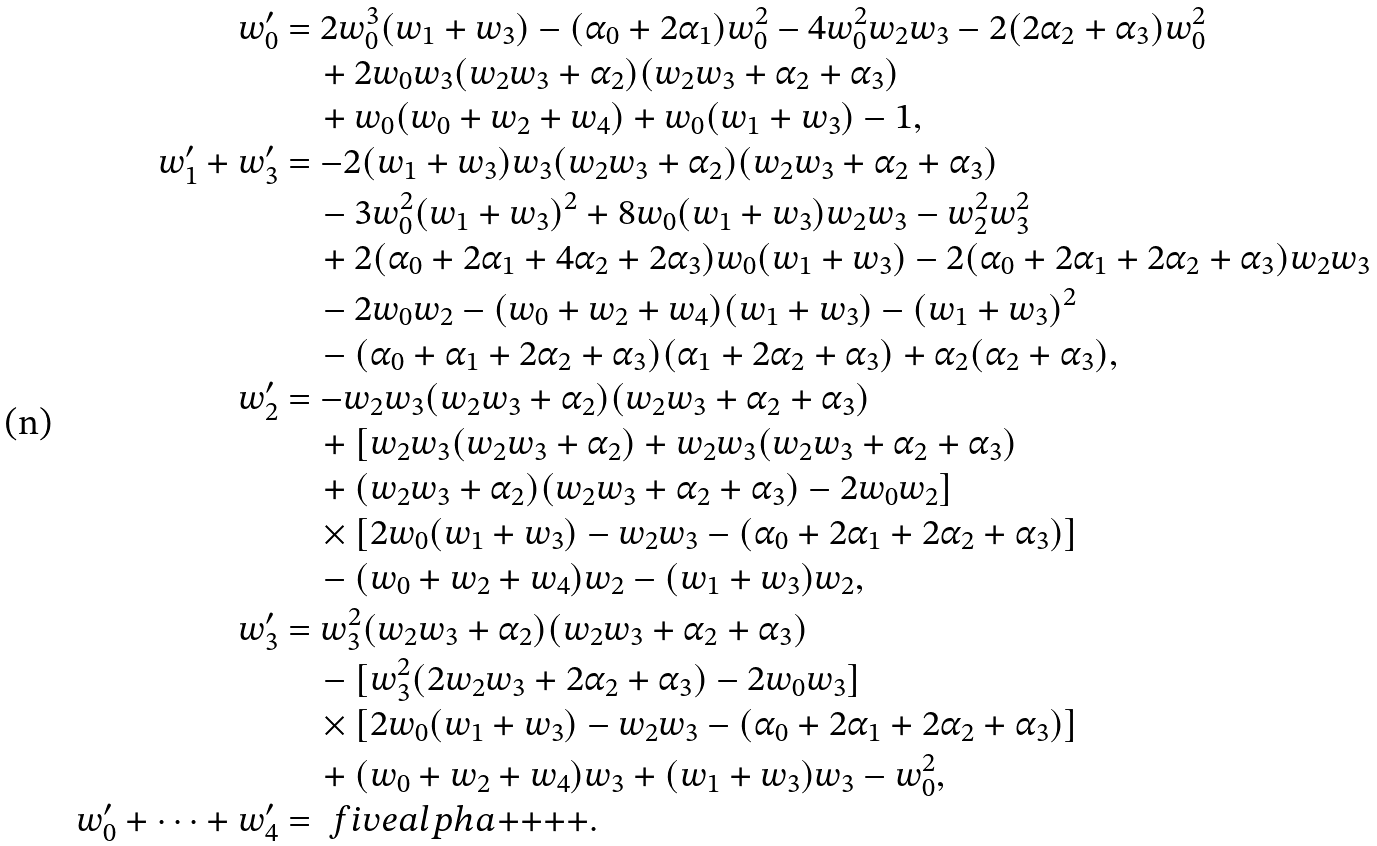<formula> <loc_0><loc_0><loc_500><loc_500>w _ { 0 } ^ { \prime } & = 2 w _ { 0 } ^ { 3 } ( w _ { 1 } + w _ { 3 } ) - ( \alpha _ { 0 } + 2 \alpha _ { 1 } ) w _ { 0 } ^ { 2 } - 4 w _ { 0 } ^ { 2 } w _ { 2 } w _ { 3 } - 2 ( 2 \alpha _ { 2 } + \alpha _ { 3 } ) w _ { 0 } ^ { 2 } \\ & \quad + 2 w _ { 0 } w _ { 3 } ( w _ { 2 } w _ { 3 } + \alpha _ { 2 } ) ( w _ { 2 } w _ { 3 } + \alpha _ { 2 } + \alpha _ { 3 } ) \\ & \quad + w _ { 0 } ( w _ { 0 } + w _ { 2 } + w _ { 4 } ) + w _ { 0 } ( w _ { 1 } + w _ { 3 } ) - 1 , \\ w _ { 1 } ^ { \prime } + w _ { 3 } ^ { \prime } & = - 2 ( w _ { 1 } + w _ { 3 } ) w _ { 3 } ( w _ { 2 } w _ { 3 } + \alpha _ { 2 } ) ( w _ { 2 } w _ { 3 } + \alpha _ { 2 } + \alpha _ { 3 } ) \\ & \quad - 3 w _ { 0 } ^ { 2 } ( w _ { 1 } + w _ { 3 } ) ^ { 2 } + 8 w _ { 0 } ( w _ { 1 } + w _ { 3 } ) w _ { 2 } w _ { 3 } - w _ { 2 } ^ { 2 } w _ { 3 } ^ { 2 } \\ & \quad + 2 ( \alpha _ { 0 } + 2 \alpha _ { 1 } + 4 \alpha _ { 2 } + 2 \alpha _ { 3 } ) w _ { 0 } ( w _ { 1 } + w _ { 3 } ) - 2 ( \alpha _ { 0 } + 2 \alpha _ { 1 } + 2 \alpha _ { 2 } + \alpha _ { 3 } ) w _ { 2 } w _ { 3 } \\ & \quad - 2 w _ { 0 } w _ { 2 } - ( w _ { 0 } + w _ { 2 } + w _ { 4 } ) ( w _ { 1 } + w _ { 3 } ) - ( w _ { 1 } + w _ { 3 } ) ^ { 2 } \\ & \quad - ( \alpha _ { 0 } + \alpha _ { 1 } + 2 \alpha _ { 2 } + \alpha _ { 3 } ) ( \alpha _ { 1 } + 2 \alpha _ { 2 } + \alpha _ { 3 } ) + \alpha _ { 2 } ( \alpha _ { 2 } + \alpha _ { 3 } ) , \\ w _ { 2 } ^ { \prime } & = - w _ { 2 } w _ { 3 } ( w _ { 2 } w _ { 3 } + \alpha _ { 2 } ) ( w _ { 2 } w _ { 3 } + \alpha _ { 2 } + \alpha _ { 3 } ) \\ & \quad + [ w _ { 2 } w _ { 3 } ( w _ { 2 } w _ { 3 } + \alpha _ { 2 } ) + w _ { 2 } w _ { 3 } ( w _ { 2 } w _ { 3 } + \alpha _ { 2 } + \alpha _ { 3 } ) \\ & \quad + ( w _ { 2 } w _ { 3 } + \alpha _ { 2 } ) ( w _ { 2 } w _ { 3 } + \alpha _ { 2 } + \alpha _ { 3 } ) - 2 w _ { 0 } w _ { 2 } ] \\ & \quad \times [ 2 w _ { 0 } ( w _ { 1 } + w _ { 3 } ) - w _ { 2 } w _ { 3 } - ( \alpha _ { 0 } + 2 \alpha _ { 1 } + 2 \alpha _ { 2 } + \alpha _ { 3 } ) ] \\ & \quad - ( w _ { 0 } + w _ { 2 } + w _ { 4 } ) w _ { 2 } - ( w _ { 1 } + w _ { 3 } ) w _ { 2 } , \\ w _ { 3 } ^ { \prime } & = w _ { 3 } ^ { 2 } ( w _ { 2 } w _ { 3 } + \alpha _ { 2 } ) ( w _ { 2 } w _ { 3 } + \alpha _ { 2 } + \alpha _ { 3 } ) \\ & \quad - [ w _ { 3 } ^ { 2 } ( 2 w _ { 2 } w _ { 3 } + 2 \alpha _ { 2 } + \alpha _ { 3 } ) - 2 w _ { 0 } w _ { 3 } ] \\ & \quad \times [ 2 w _ { 0 } ( w _ { 1 } + w _ { 3 } ) - w _ { 2 } w _ { 3 } - ( \alpha _ { 0 } + 2 \alpha _ { 1 } + 2 \alpha _ { 2 } + \alpha _ { 3 } ) ] \\ & \quad + ( w _ { 0 } + w _ { 2 } + w _ { 4 } ) w _ { 3 } + ( w _ { 1 } + w _ { 3 } ) w _ { 3 } - w _ { 0 } ^ { 2 } , \\ w _ { 0 } ^ { \prime } + \cdots + w _ { 4 } ^ { \prime } & = \ f i v e a l p h a { + } { + } { + } { + } .</formula> 